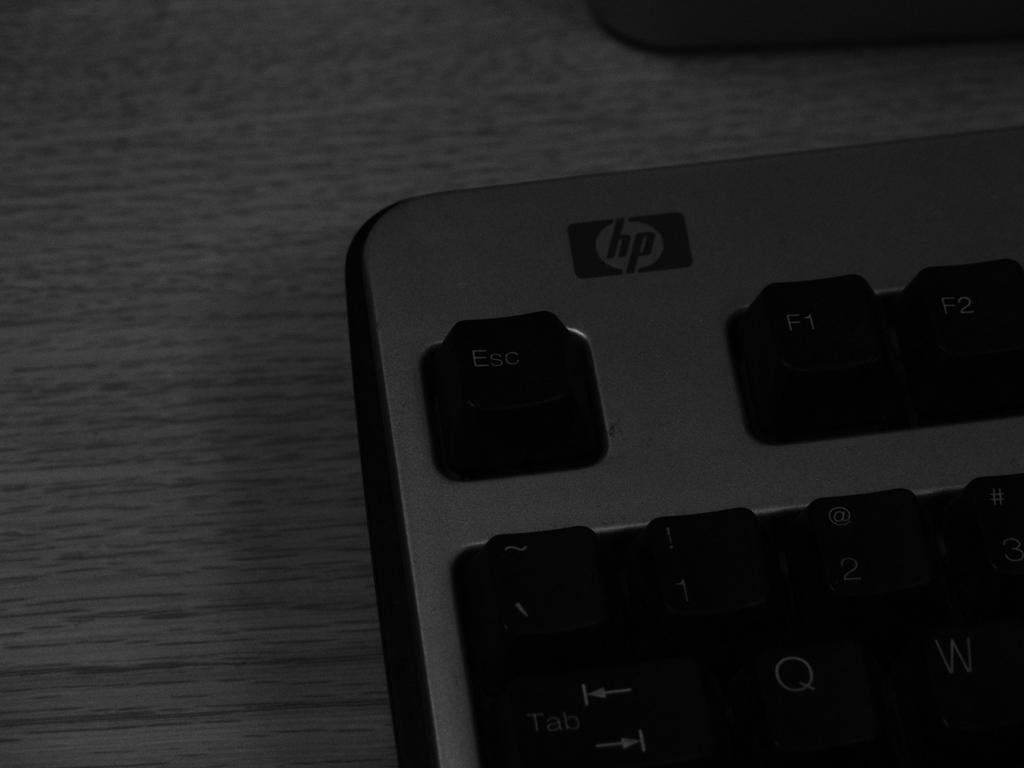<image>
Give a short and clear explanation of the subsequent image. A grey and black HP keyboard laying on a desk. 